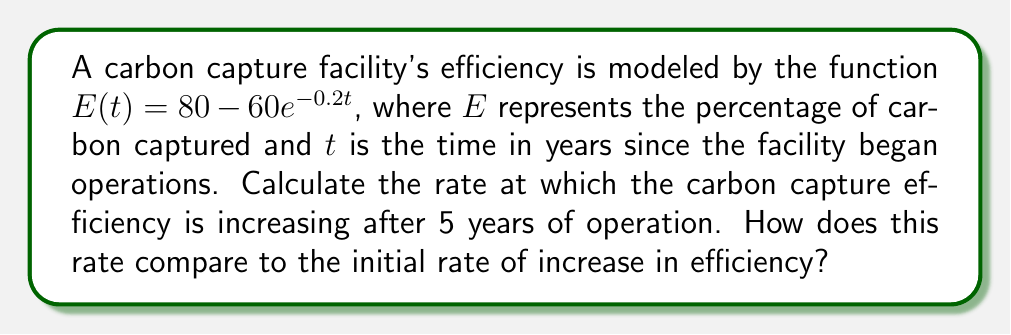Provide a solution to this math problem. To solve this problem, we need to use derivatives to analyze the rate of change in carbon capture efficiency over time.

1. First, let's find the derivative of $E(t)$ with respect to $t$:
   $$\frac{dE}{dt} = \frac{d}{dt}(80 - 60e^{-0.2t}) = 60 \cdot 0.2e^{-0.2t} = 12e^{-0.2t}$$

2. This derivative represents the instantaneous rate of change in efficiency at any given time $t$.

3. To find the rate of increase after 5 years, we evaluate the derivative at $t=5$:
   $$\frac{dE}{dt}\bigg|_{t=5} = 12e^{-0.2(5)} = 12e^{-1} \approx 4.42\% \text{ per year}$$

4. To find the initial rate of increase, we evaluate the derivative at $t=0$:
   $$\frac{dE}{dt}\bigg|_{t=0} = 12e^{-0.2(0)} = 12\% \text{ per year}$$

5. To compare these rates, we can calculate the ratio:
   $$\frac{\text{Rate at 5 years}}{\text{Initial rate}} = \frac{4.42}{12} \approx 0.368 \text{ or } 36.8\%$$

This means that after 5 years, the rate of efficiency increase is about 36.8% of the initial rate.
Answer: The rate of increase in carbon capture efficiency after 5 years is approximately 4.42% per year. This rate is about 36.8% of the initial rate of increase, which was 12% per year. 